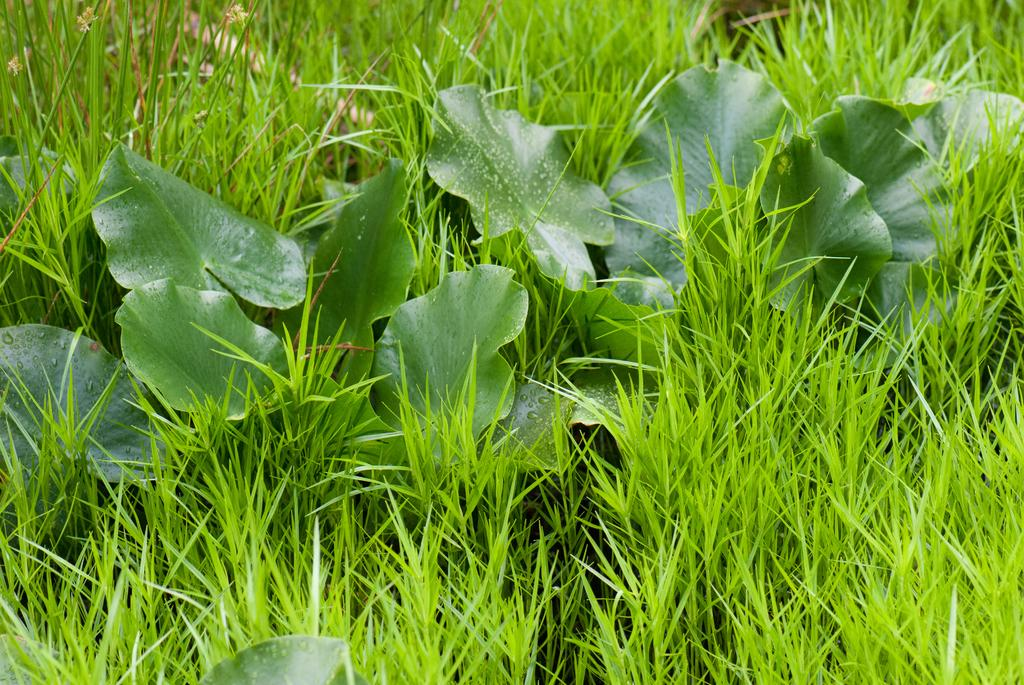Where was the image taken? The image was taken outdoors. What type of surface can be seen in the image? There is a ground with grass in the image. Are there any objects on the ground in the image? Yes, there are a few leaves on the ground in the middle of the image. What type of toys can be seen scattered on the plantation in the image? There is no plantation or toys present in the image; it features a ground with grass and leaves. 